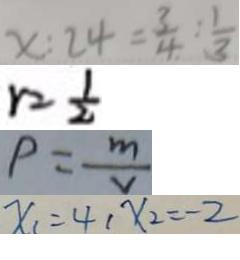<formula> <loc_0><loc_0><loc_500><loc_500>x : 2 4 = \frac { 3 } { 4 } : \frac { 1 } { 3 } 
 r = \frac { 1 } { 2 } 
 P = \frac { m } { v } 
 x _ { 1 } = 4 , x _ { 2 } = - 2</formula> 